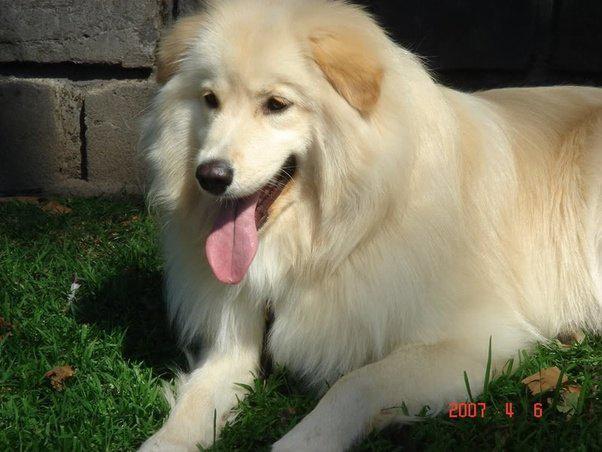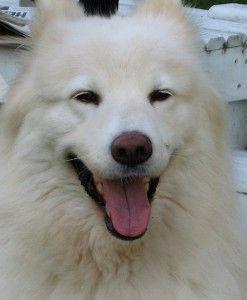The first image is the image on the left, the second image is the image on the right. Given the left and right images, does the statement "in the left pic the dog is in a form of grass" hold true? Answer yes or no. Yes. The first image is the image on the left, the second image is the image on the right. For the images shown, is this caption "Both white dogs have their tongues hanging out of their mouths." true? Answer yes or no. Yes. 